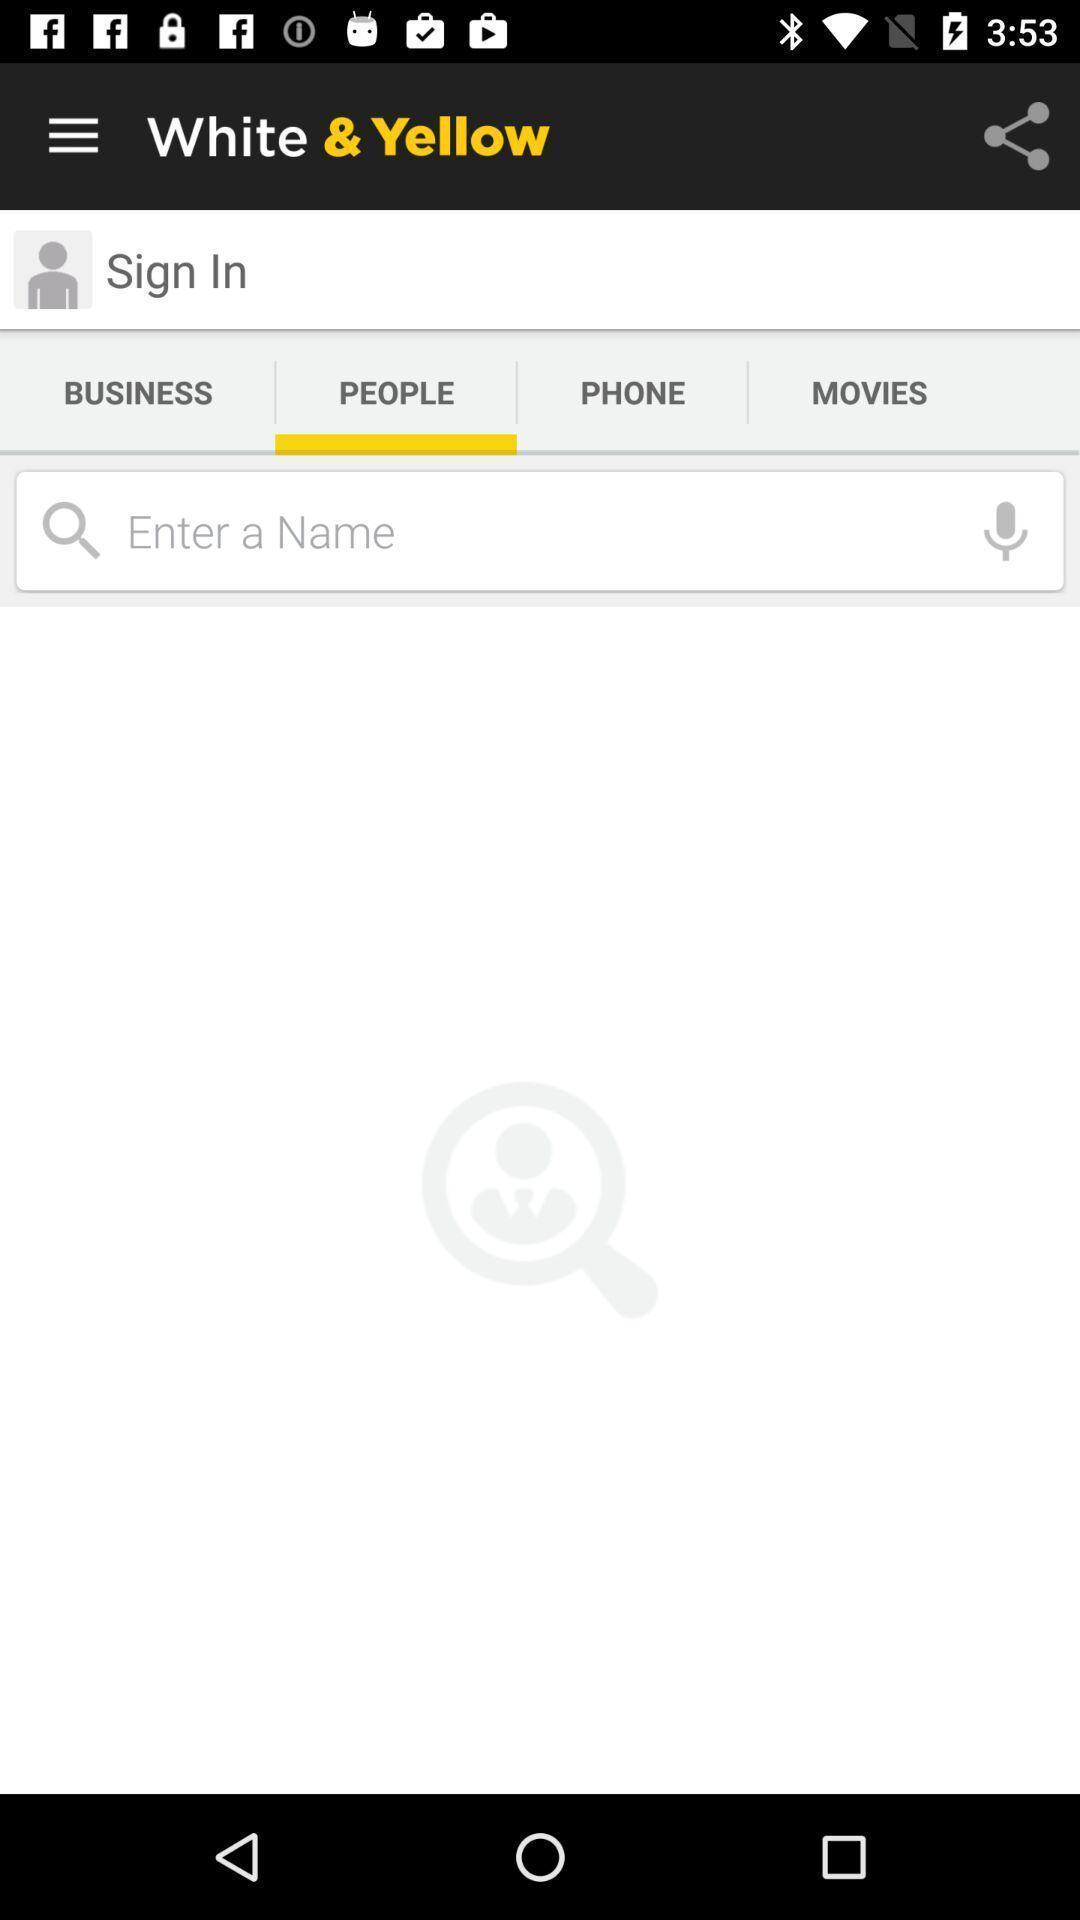Summarize the main components in this picture. Searching option to find people in the business app. 